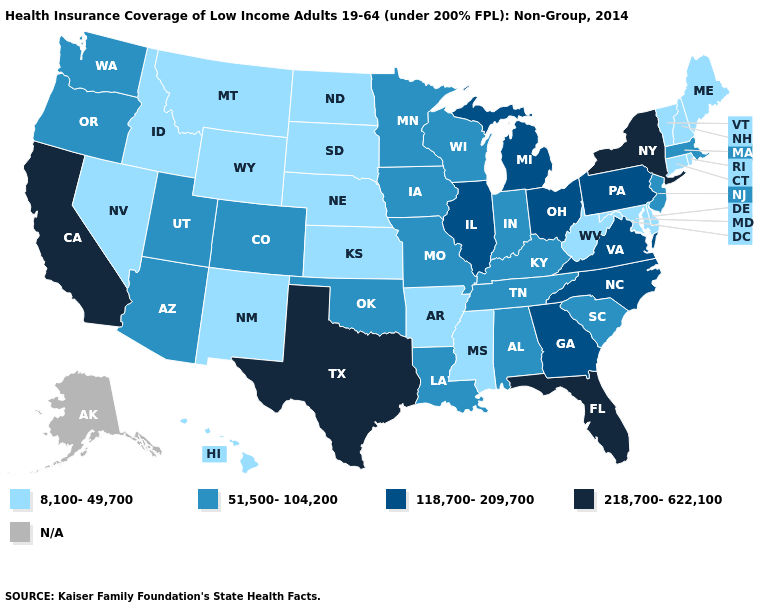Does Arizona have the lowest value in the West?
Be succinct. No. Name the states that have a value in the range 8,100-49,700?
Quick response, please. Arkansas, Connecticut, Delaware, Hawaii, Idaho, Kansas, Maine, Maryland, Mississippi, Montana, Nebraska, Nevada, New Hampshire, New Mexico, North Dakota, Rhode Island, South Dakota, Vermont, West Virginia, Wyoming. Which states have the highest value in the USA?
Answer briefly. California, Florida, New York, Texas. Among the states that border Oregon , does Washington have the lowest value?
Be succinct. No. What is the lowest value in the USA?
Concise answer only. 8,100-49,700. What is the highest value in states that border Minnesota?
Be succinct. 51,500-104,200. Name the states that have a value in the range 8,100-49,700?
Write a very short answer. Arkansas, Connecticut, Delaware, Hawaii, Idaho, Kansas, Maine, Maryland, Mississippi, Montana, Nebraska, Nevada, New Hampshire, New Mexico, North Dakota, Rhode Island, South Dakota, Vermont, West Virginia, Wyoming. Is the legend a continuous bar?
Short answer required. No. What is the value of Arkansas?
Short answer required. 8,100-49,700. Does Ohio have the highest value in the MidWest?
Answer briefly. Yes. What is the value of Georgia?
Quick response, please. 118,700-209,700. What is the lowest value in states that border Wyoming?
Be succinct. 8,100-49,700. Name the states that have a value in the range N/A?
Be succinct. Alaska. Does Missouri have the highest value in the MidWest?
Short answer required. No. Which states have the highest value in the USA?
Write a very short answer. California, Florida, New York, Texas. 